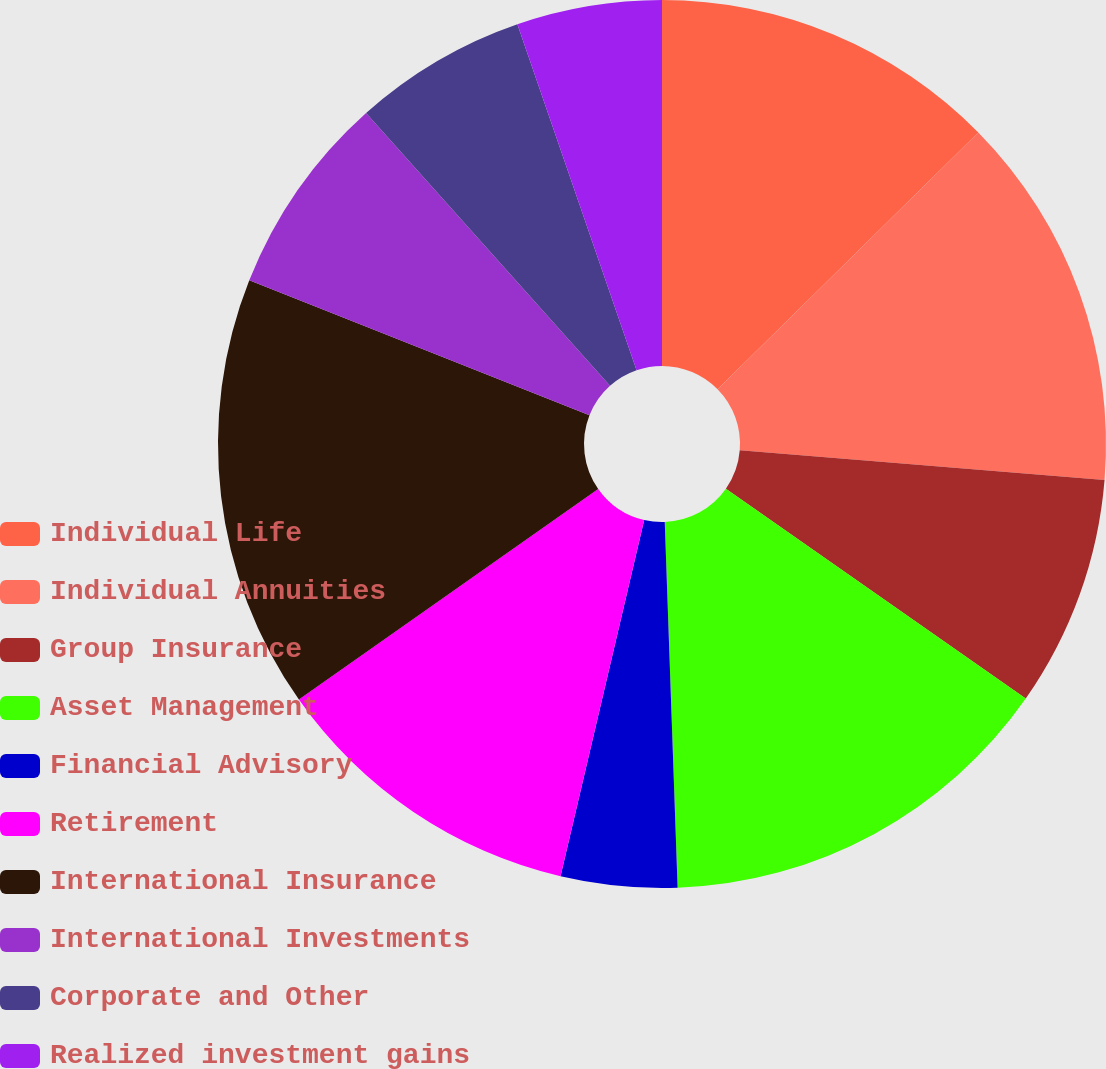Convert chart. <chart><loc_0><loc_0><loc_500><loc_500><pie_chart><fcel>Individual Life<fcel>Individual Annuities<fcel>Group Insurance<fcel>Asset Management<fcel>Financial Advisory<fcel>Retirement<fcel>International Insurance<fcel>International Investments<fcel>Corporate and Other<fcel>Realized investment gains<nl><fcel>12.62%<fcel>13.67%<fcel>8.43%<fcel>14.72%<fcel>4.23%<fcel>11.57%<fcel>15.77%<fcel>7.38%<fcel>6.33%<fcel>5.28%<nl></chart> 